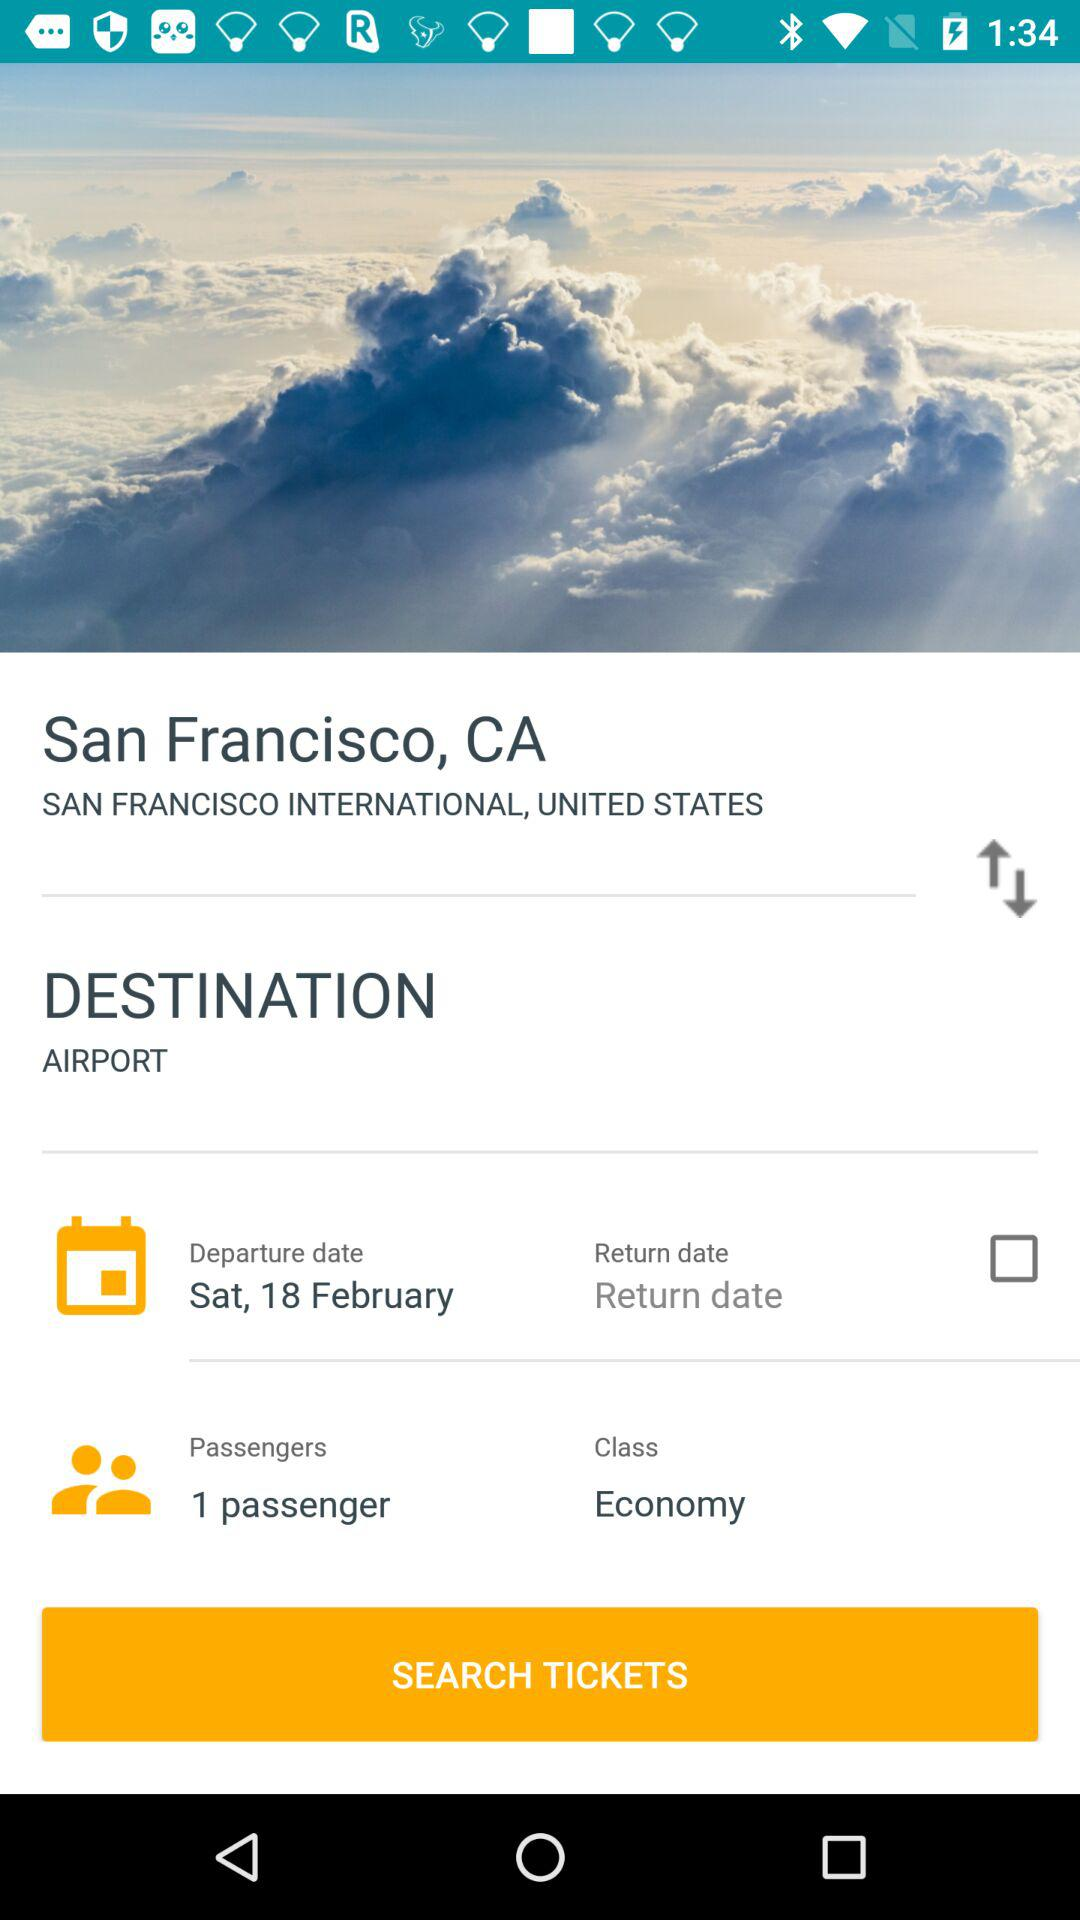What's the class? The class is Economy. 